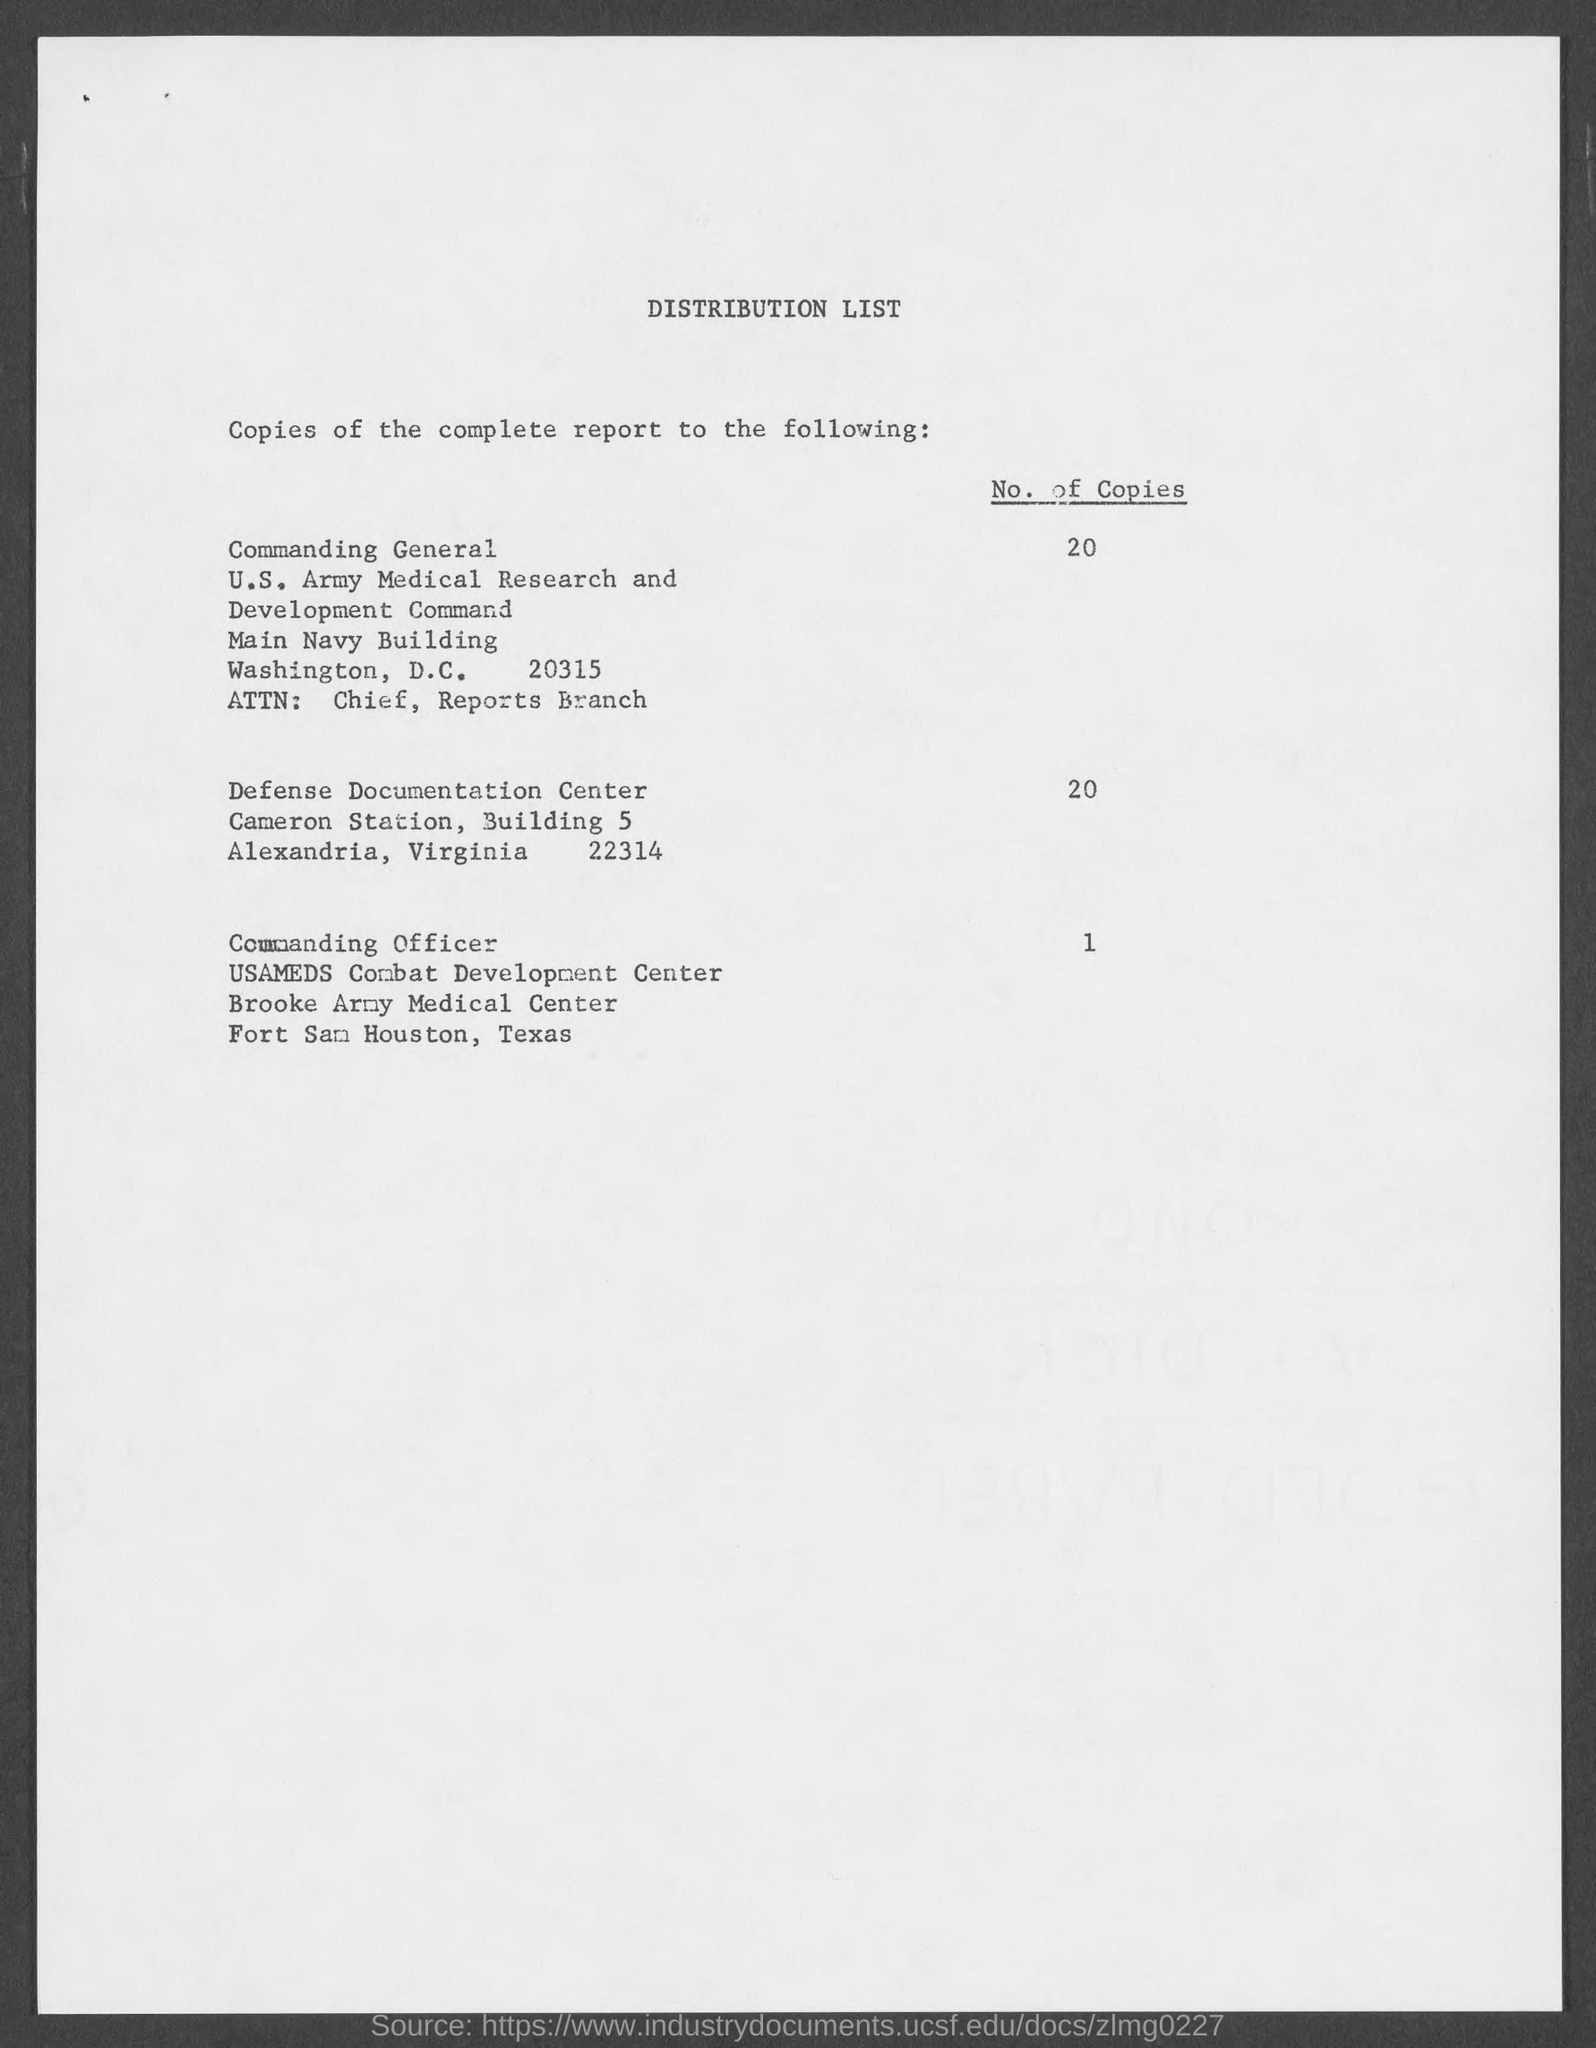Indicate a few pertinent items in this graphic. The distribution of the complete report includes the distribution of 20 copies to the Commanding General. The title of the document is 'Distribution List'. The distribution of the complete report to the Commanding Officer is limited to 1 copy. The number of copies of the complete report distributed to the Defense Documentation Center is 20. 